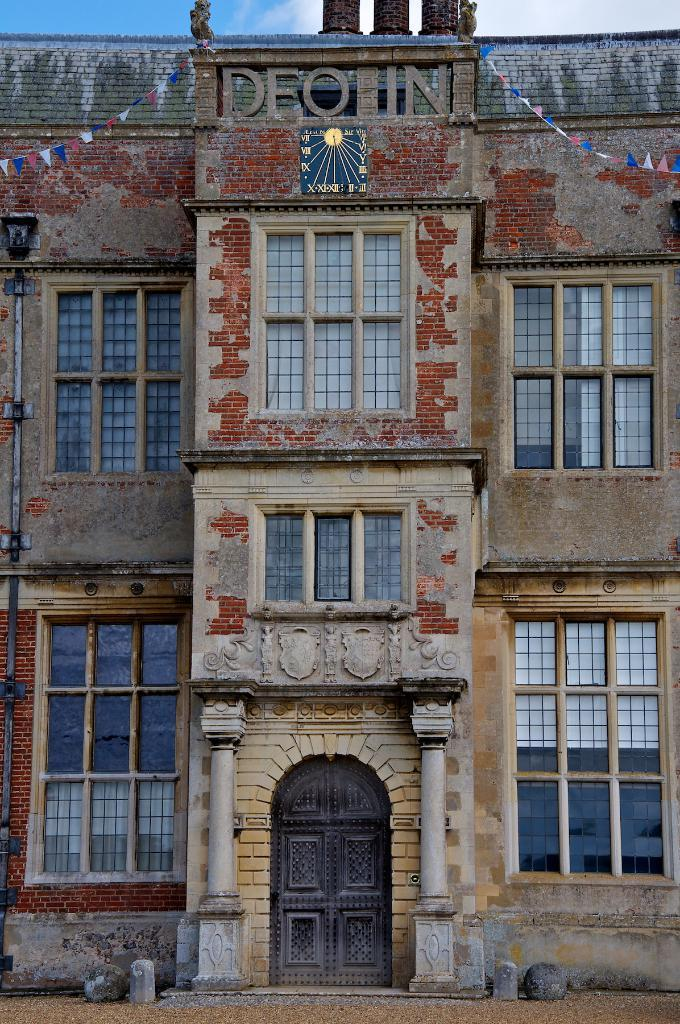What type of structure is present in the image? There is a building in the image. What feature can be observed on the building? The building has glass windows. What is visible at the top of the image? The sky is visible at the top of the image. How many cars are parked in front of the building in the image? There is no information about cars in the image, as the facts provided only mention the building and its features. 